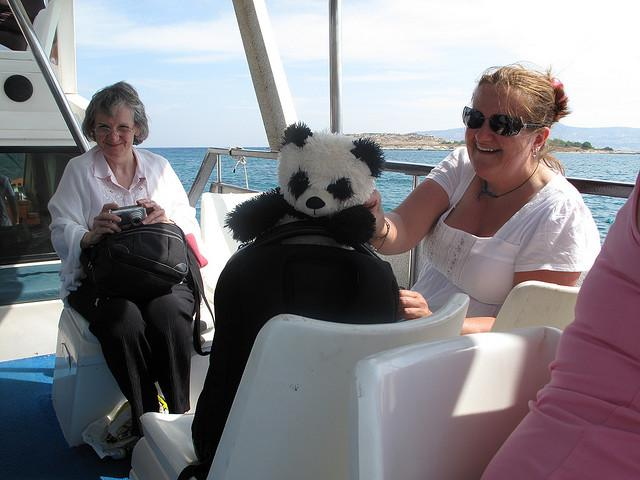What digital device is being used to capture memories? camera 